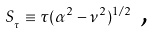<formula> <loc_0><loc_0><loc_500><loc_500>S _ { _ { \tau } } \equiv \tau ( \alpha ^ { 2 } - \nu ^ { 2 } ) ^ { 1 / 2 } \text { ,}</formula> 